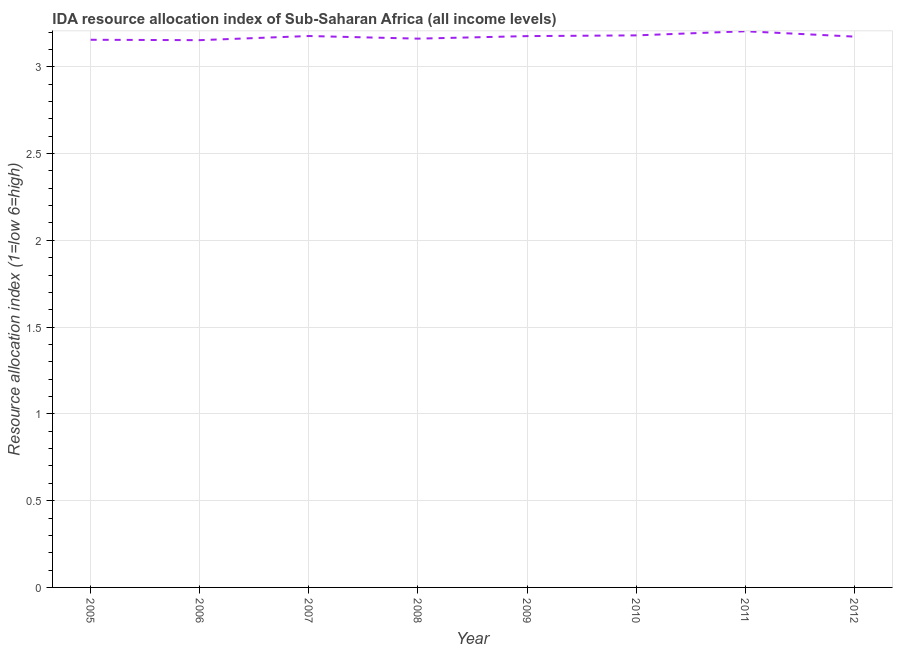What is the ida resource allocation index in 2006?
Your response must be concise. 3.15. Across all years, what is the maximum ida resource allocation index?
Offer a terse response. 3.2. Across all years, what is the minimum ida resource allocation index?
Ensure brevity in your answer.  3.15. What is the sum of the ida resource allocation index?
Offer a terse response. 25.38. What is the difference between the ida resource allocation index in 2005 and 2009?
Give a very brief answer. -0.02. What is the average ida resource allocation index per year?
Ensure brevity in your answer.  3.17. What is the median ida resource allocation index?
Provide a short and direct response. 3.18. What is the ratio of the ida resource allocation index in 2005 to that in 2008?
Your answer should be compact. 1. Is the ida resource allocation index in 2011 less than that in 2012?
Provide a succinct answer. No. What is the difference between the highest and the second highest ida resource allocation index?
Make the answer very short. 0.02. Is the sum of the ida resource allocation index in 2005 and 2009 greater than the maximum ida resource allocation index across all years?
Keep it short and to the point. Yes. What is the difference between the highest and the lowest ida resource allocation index?
Provide a short and direct response. 0.05. Does the ida resource allocation index monotonically increase over the years?
Give a very brief answer. No. How many years are there in the graph?
Your answer should be very brief. 8. What is the difference between two consecutive major ticks on the Y-axis?
Provide a succinct answer. 0.5. Are the values on the major ticks of Y-axis written in scientific E-notation?
Provide a short and direct response. No. Does the graph contain grids?
Offer a very short reply. Yes. What is the title of the graph?
Ensure brevity in your answer.  IDA resource allocation index of Sub-Saharan Africa (all income levels). What is the label or title of the X-axis?
Ensure brevity in your answer.  Year. What is the label or title of the Y-axis?
Your answer should be compact. Resource allocation index (1=low 6=high). What is the Resource allocation index (1=low 6=high) in 2005?
Provide a succinct answer. 3.16. What is the Resource allocation index (1=low 6=high) in 2006?
Offer a very short reply. 3.15. What is the Resource allocation index (1=low 6=high) in 2007?
Offer a terse response. 3.18. What is the Resource allocation index (1=low 6=high) in 2008?
Ensure brevity in your answer.  3.16. What is the Resource allocation index (1=low 6=high) of 2009?
Keep it short and to the point. 3.18. What is the Resource allocation index (1=low 6=high) in 2010?
Your answer should be very brief. 3.18. What is the Resource allocation index (1=low 6=high) of 2011?
Keep it short and to the point. 3.2. What is the Resource allocation index (1=low 6=high) in 2012?
Ensure brevity in your answer.  3.17. What is the difference between the Resource allocation index (1=low 6=high) in 2005 and 2006?
Give a very brief answer. 0. What is the difference between the Resource allocation index (1=low 6=high) in 2005 and 2007?
Your answer should be compact. -0.02. What is the difference between the Resource allocation index (1=low 6=high) in 2005 and 2008?
Give a very brief answer. -0.01. What is the difference between the Resource allocation index (1=low 6=high) in 2005 and 2009?
Offer a very short reply. -0.02. What is the difference between the Resource allocation index (1=low 6=high) in 2005 and 2010?
Provide a short and direct response. -0.03. What is the difference between the Resource allocation index (1=low 6=high) in 2005 and 2011?
Make the answer very short. -0.05. What is the difference between the Resource allocation index (1=low 6=high) in 2005 and 2012?
Your answer should be compact. -0.02. What is the difference between the Resource allocation index (1=low 6=high) in 2006 and 2007?
Provide a succinct answer. -0.02. What is the difference between the Resource allocation index (1=low 6=high) in 2006 and 2008?
Your response must be concise. -0.01. What is the difference between the Resource allocation index (1=low 6=high) in 2006 and 2009?
Provide a short and direct response. -0.02. What is the difference between the Resource allocation index (1=low 6=high) in 2006 and 2010?
Provide a short and direct response. -0.03. What is the difference between the Resource allocation index (1=low 6=high) in 2006 and 2011?
Ensure brevity in your answer.  -0.05. What is the difference between the Resource allocation index (1=low 6=high) in 2006 and 2012?
Give a very brief answer. -0.02. What is the difference between the Resource allocation index (1=low 6=high) in 2007 and 2008?
Keep it short and to the point. 0.02. What is the difference between the Resource allocation index (1=low 6=high) in 2007 and 2009?
Offer a terse response. 0. What is the difference between the Resource allocation index (1=low 6=high) in 2007 and 2010?
Your response must be concise. -0. What is the difference between the Resource allocation index (1=low 6=high) in 2007 and 2011?
Offer a very short reply. -0.03. What is the difference between the Resource allocation index (1=low 6=high) in 2007 and 2012?
Keep it short and to the point. 0. What is the difference between the Resource allocation index (1=low 6=high) in 2008 and 2009?
Provide a succinct answer. -0.01. What is the difference between the Resource allocation index (1=low 6=high) in 2008 and 2010?
Provide a succinct answer. -0.02. What is the difference between the Resource allocation index (1=low 6=high) in 2008 and 2011?
Offer a very short reply. -0.04. What is the difference between the Resource allocation index (1=low 6=high) in 2008 and 2012?
Make the answer very short. -0.01. What is the difference between the Resource allocation index (1=low 6=high) in 2009 and 2010?
Your answer should be compact. -0. What is the difference between the Resource allocation index (1=low 6=high) in 2009 and 2011?
Give a very brief answer. -0.03. What is the difference between the Resource allocation index (1=low 6=high) in 2009 and 2012?
Ensure brevity in your answer.  0. What is the difference between the Resource allocation index (1=low 6=high) in 2010 and 2011?
Provide a succinct answer. -0.02. What is the difference between the Resource allocation index (1=low 6=high) in 2010 and 2012?
Your response must be concise. 0.01. What is the difference between the Resource allocation index (1=low 6=high) in 2011 and 2012?
Your answer should be very brief. 0.03. What is the ratio of the Resource allocation index (1=low 6=high) in 2005 to that in 2006?
Provide a short and direct response. 1. What is the ratio of the Resource allocation index (1=low 6=high) in 2005 to that in 2008?
Make the answer very short. 1. What is the ratio of the Resource allocation index (1=low 6=high) in 2005 to that in 2009?
Offer a very short reply. 0.99. What is the ratio of the Resource allocation index (1=low 6=high) in 2005 to that in 2011?
Offer a terse response. 0.98. What is the ratio of the Resource allocation index (1=low 6=high) in 2005 to that in 2012?
Your answer should be compact. 0.99. What is the ratio of the Resource allocation index (1=low 6=high) in 2006 to that in 2009?
Offer a terse response. 0.99. What is the ratio of the Resource allocation index (1=low 6=high) in 2006 to that in 2011?
Offer a terse response. 0.98. What is the ratio of the Resource allocation index (1=low 6=high) in 2007 to that in 2008?
Offer a very short reply. 1. What is the ratio of the Resource allocation index (1=low 6=high) in 2007 to that in 2010?
Give a very brief answer. 1. What is the ratio of the Resource allocation index (1=low 6=high) in 2009 to that in 2010?
Offer a terse response. 1. What is the ratio of the Resource allocation index (1=low 6=high) in 2009 to that in 2012?
Keep it short and to the point. 1. What is the ratio of the Resource allocation index (1=low 6=high) in 2010 to that in 2012?
Provide a short and direct response. 1. 